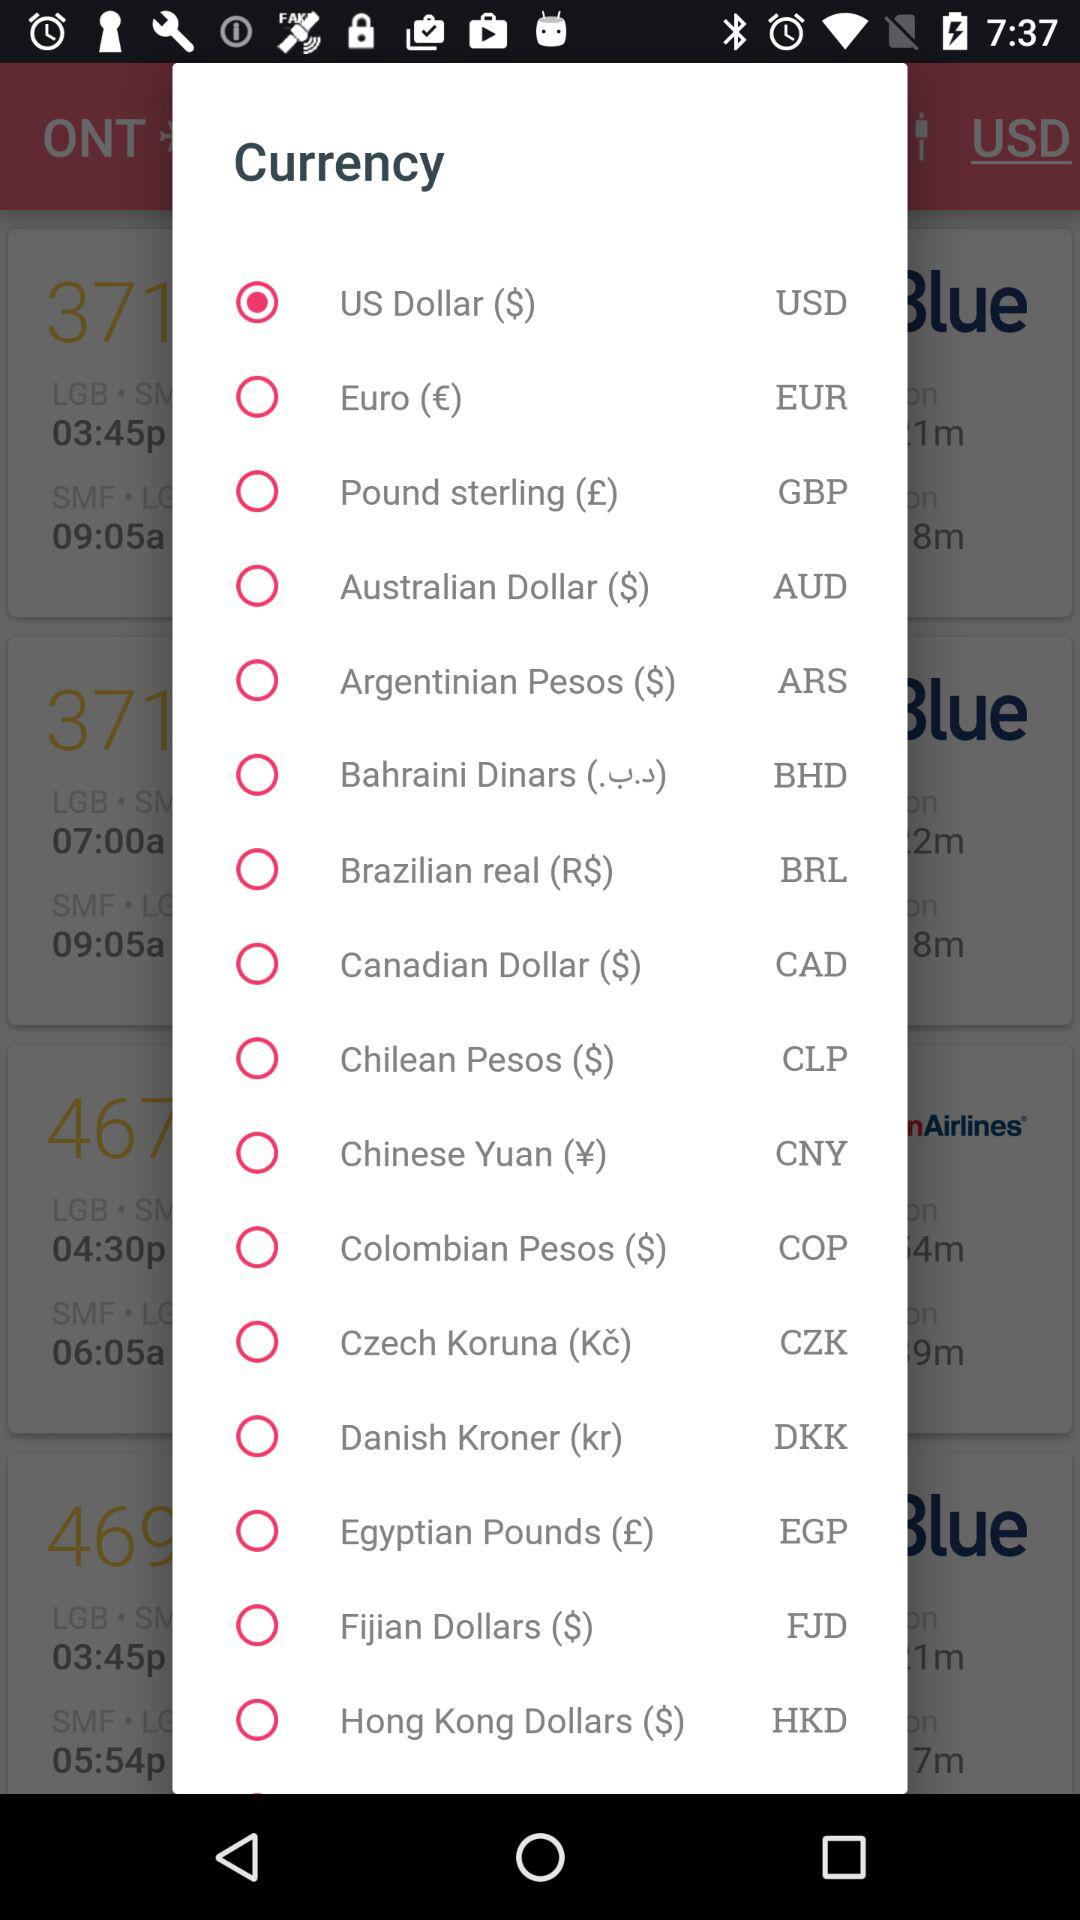Which option is selected? The selected option is "US Dollar ($)". 